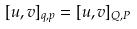<formula> <loc_0><loc_0><loc_500><loc_500>[ u , v ] _ { q , p } = [ u , v ] _ { Q , P }</formula> 